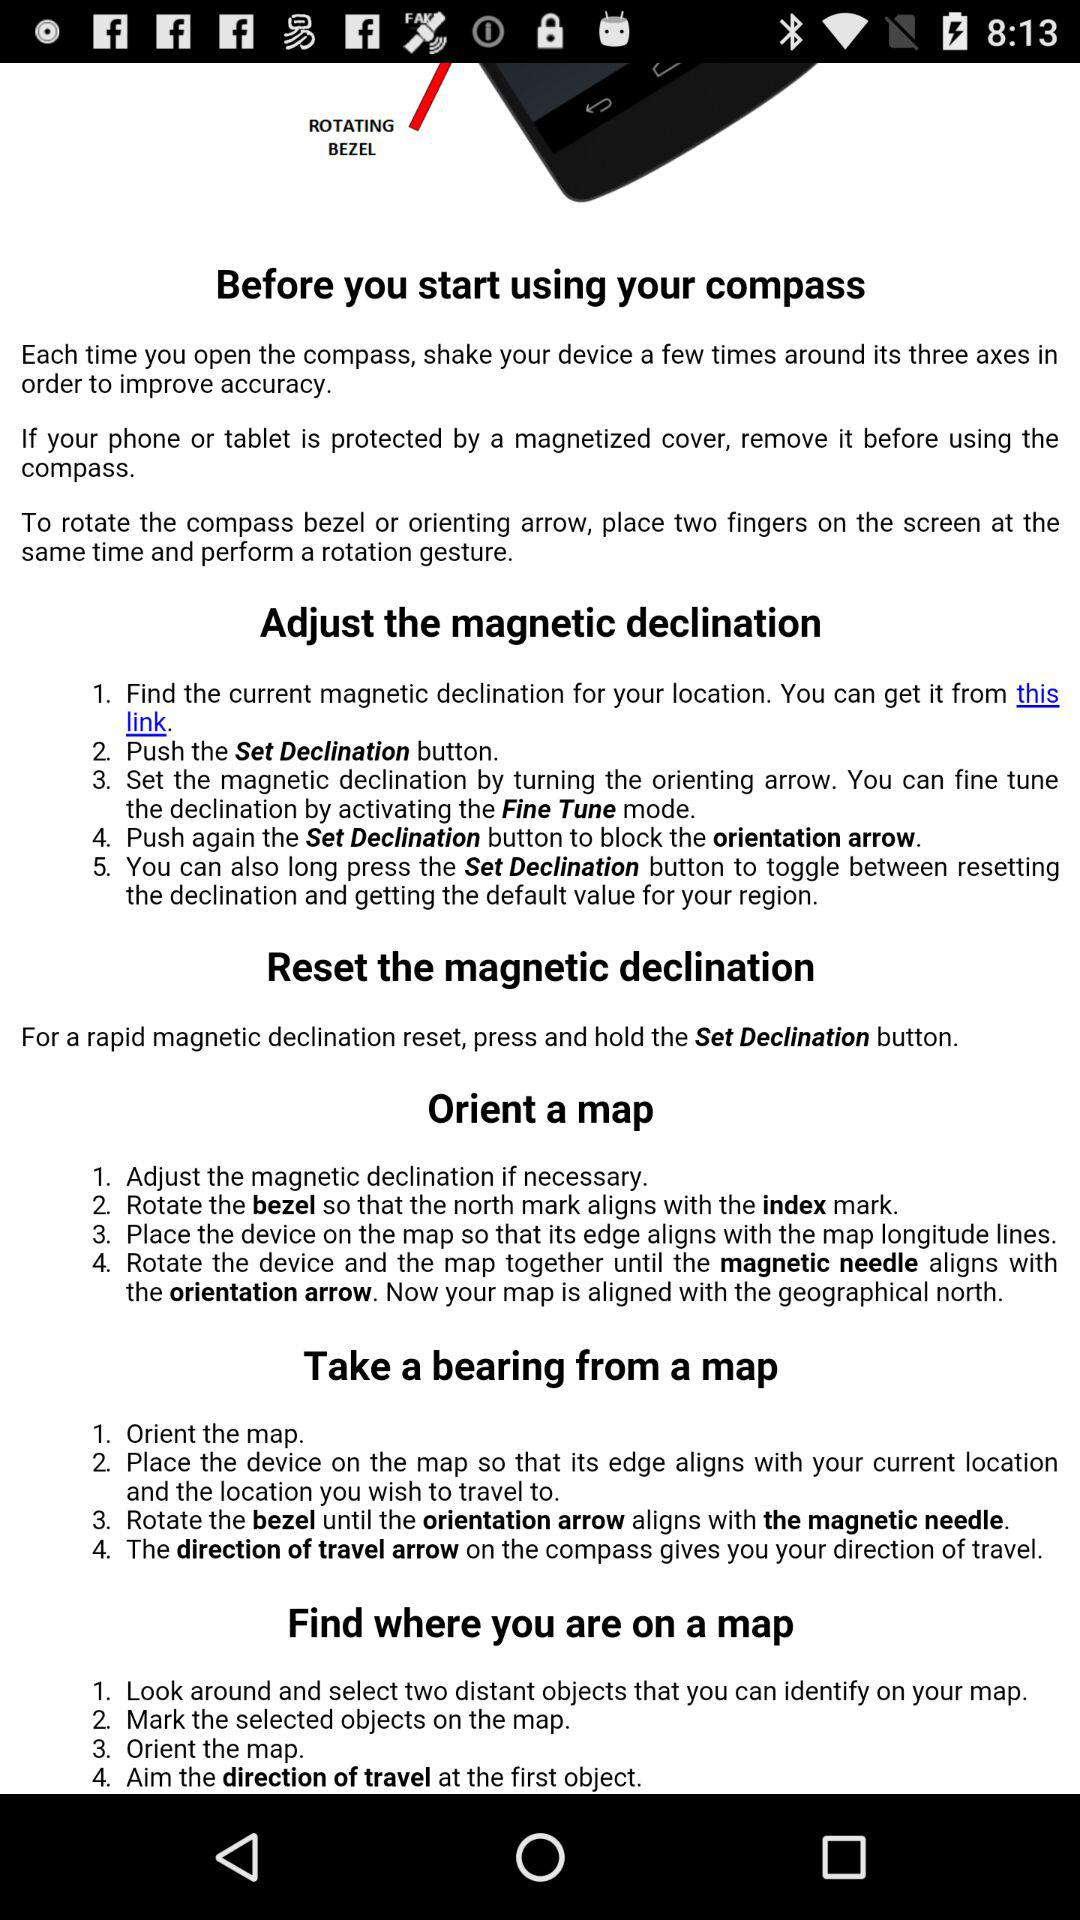How many steps are required to orient a map?
Answer the question using a single word or phrase. 4 